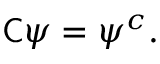<formula> <loc_0><loc_0><loc_500><loc_500>{ C } \psi = \psi ^ { c } .</formula> 